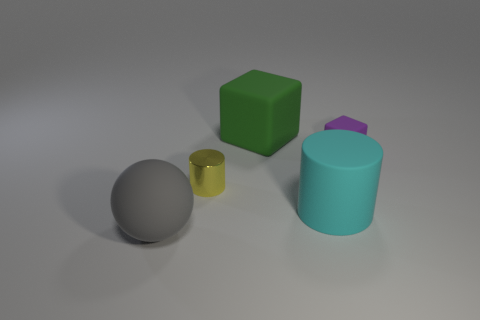How many shiny things are either big green blocks or tiny cyan spheres?
Your answer should be compact. 0. There is a cube that is in front of the thing that is behind the small block; are there any cylinders on the left side of it?
Offer a very short reply. Yes. The purple object that is the same material as the large gray sphere is what size?
Your response must be concise. Small. Are there any large objects on the right side of the tiny purple matte object?
Offer a very short reply. No. Is there a big green rubber cube in front of the large matte object that is to the left of the tiny shiny cylinder?
Make the answer very short. No. Does the matte block behind the purple cube have the same size as the cylinder that is behind the large cyan cylinder?
Give a very brief answer. No. What number of tiny objects are green metal balls or cyan matte cylinders?
Offer a terse response. 0. What material is the block that is in front of the green matte cube that is to the right of the tiny yellow shiny object made of?
Provide a succinct answer. Rubber. Are there any other green cubes made of the same material as the big block?
Your answer should be compact. No. Does the tiny purple object have the same material as the object in front of the large cyan matte object?
Offer a very short reply. Yes. 